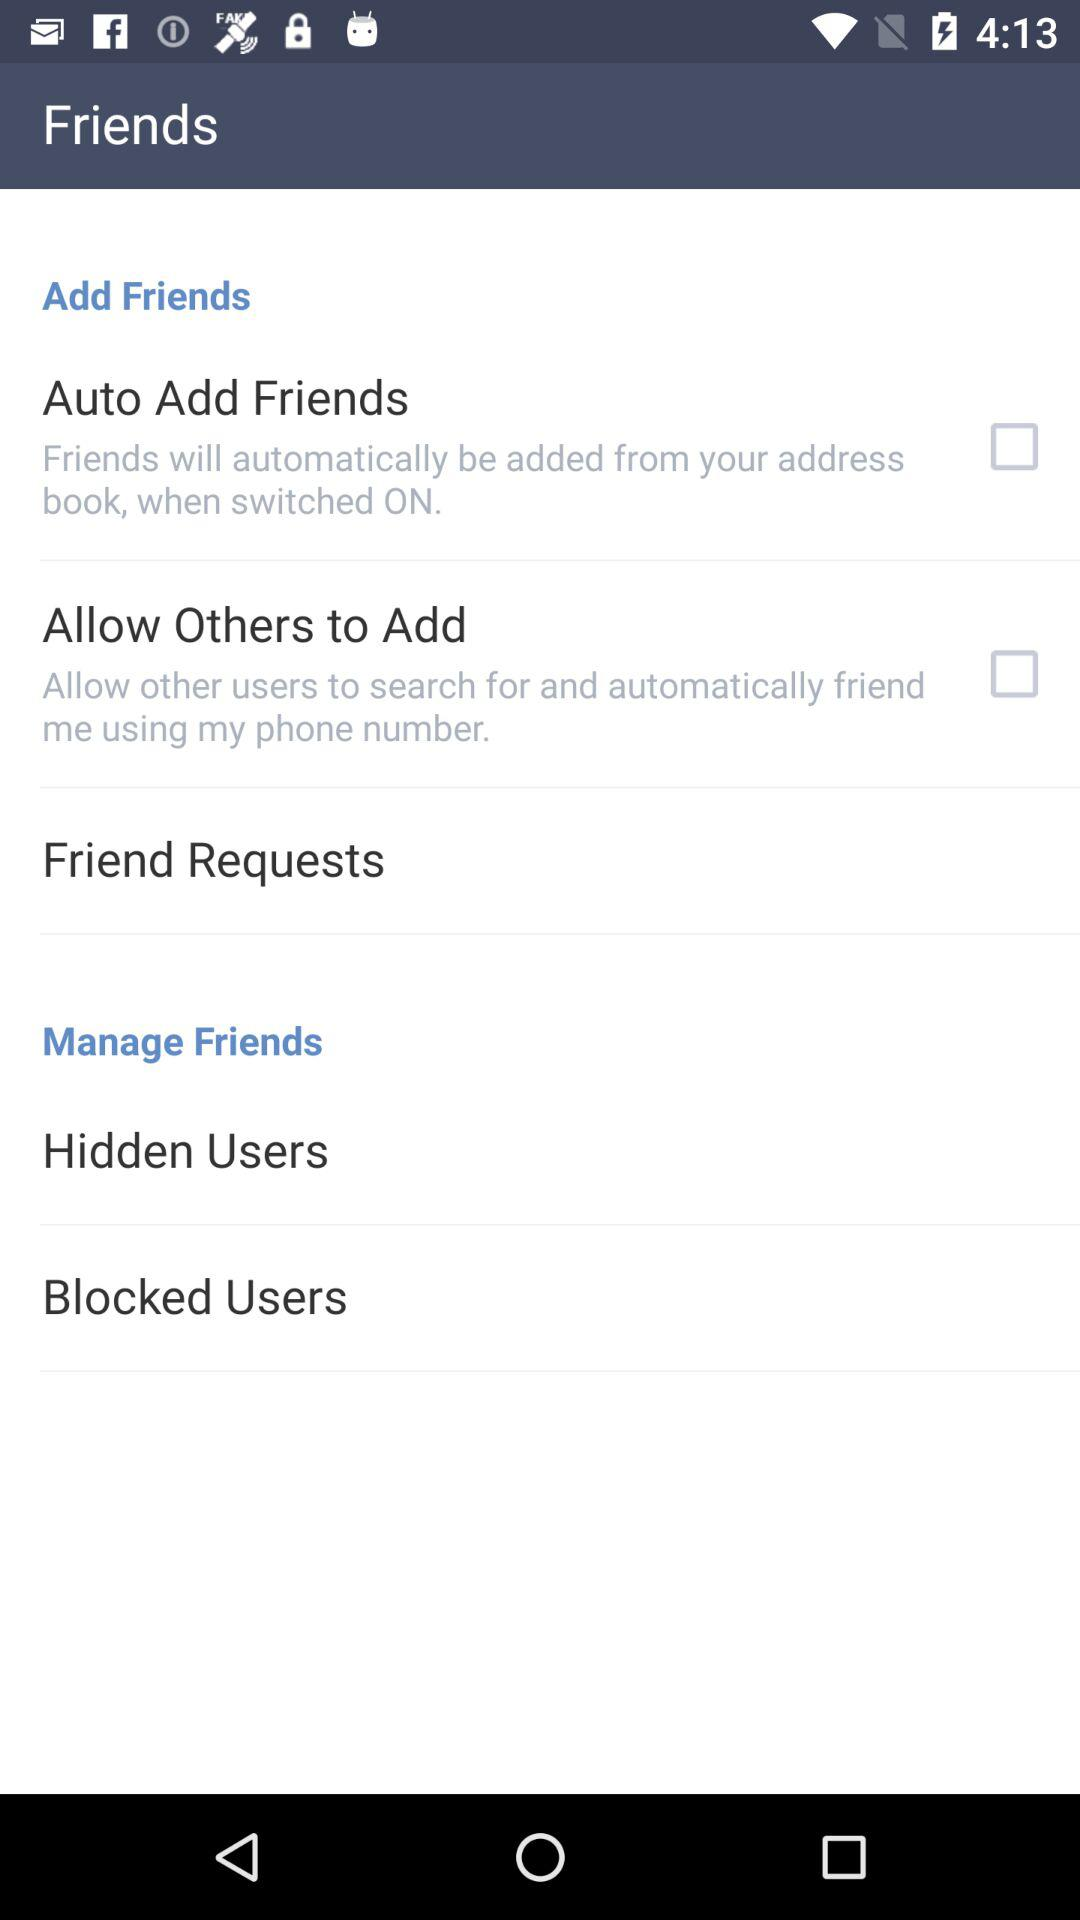How many items are in the Friends section?
Answer the question using a single word or phrase. 5 